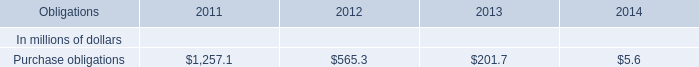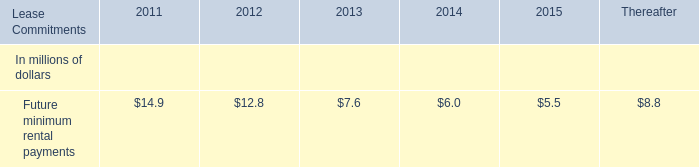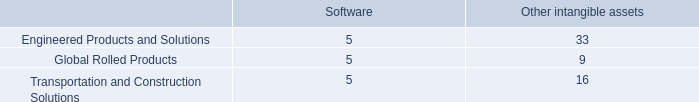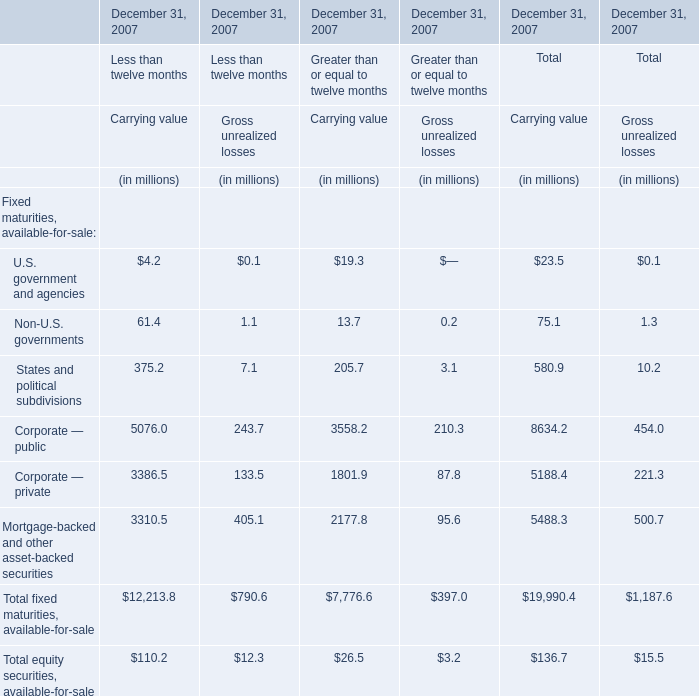What was the average value of States and political subdivisions, Corporate — public, Corporate — private for Carrying value of Greater than or equal to twelve months? (in million) 
Computations: (((205.7 + 3558.2) + 1801.9) / 3)
Answer: 1855.26667. 